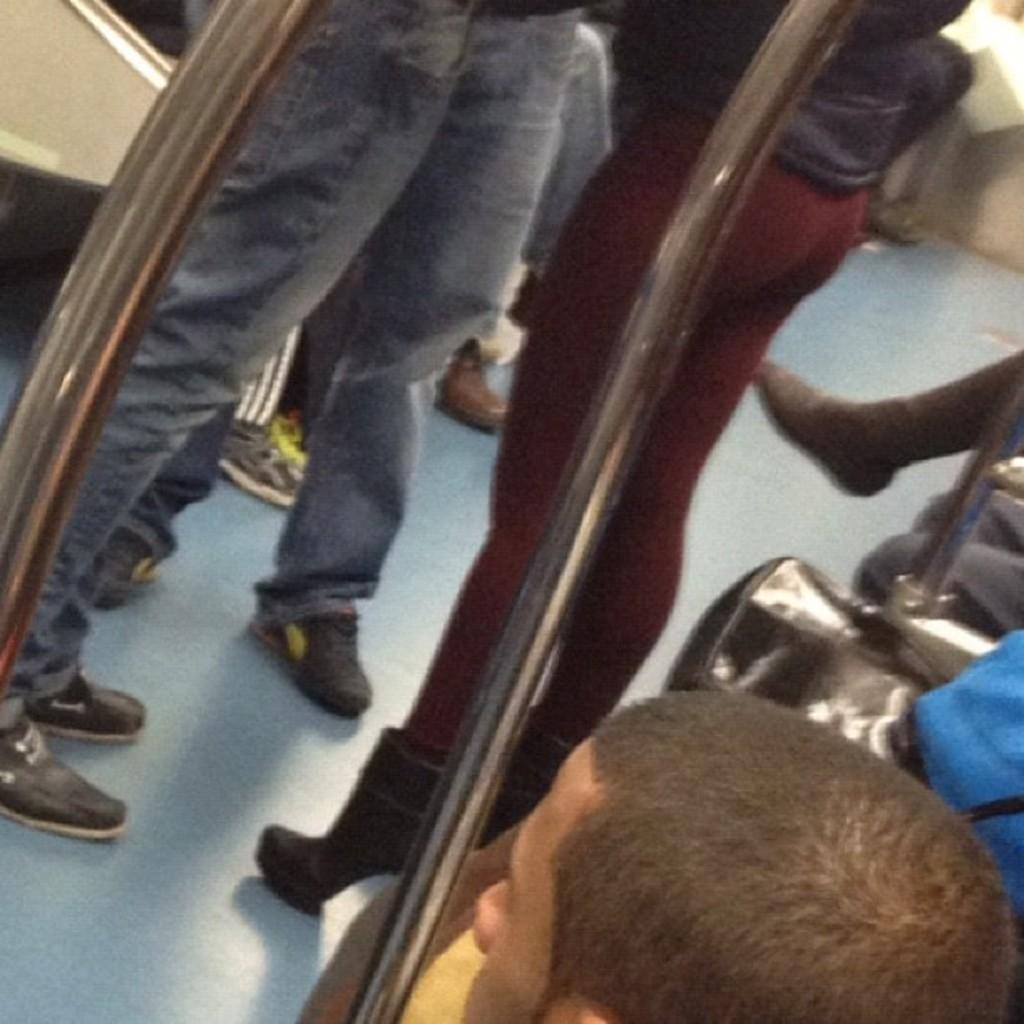Please provide a concise description of this image. In this image I can see a group of people are standing may be in a vehicle and few are sitting on the seats. This image is taken may be in a vehicle. 